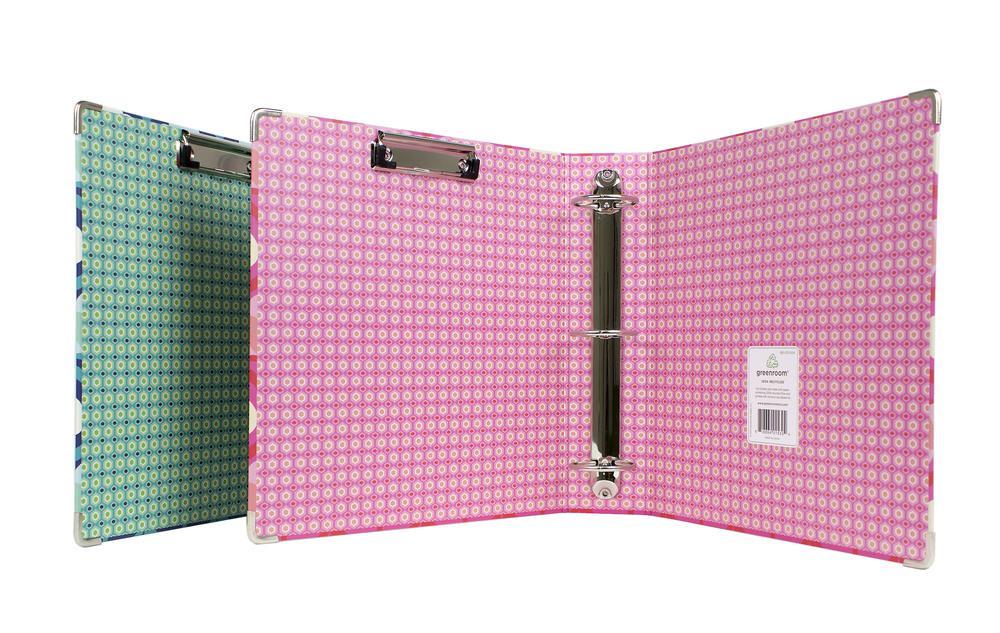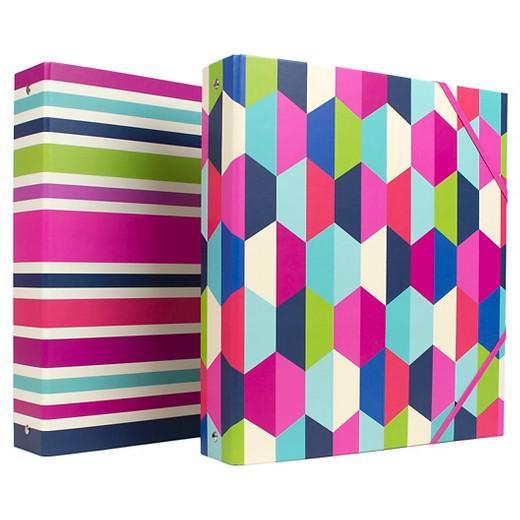The first image is the image on the left, the second image is the image on the right. Examine the images to the left and right. Is the description "At least one of the binders is open." accurate? Answer yes or no. Yes. The first image is the image on the left, the second image is the image on the right. Considering the images on both sides, is "One binder is open and showing its prongs." valid? Answer yes or no. Yes. 